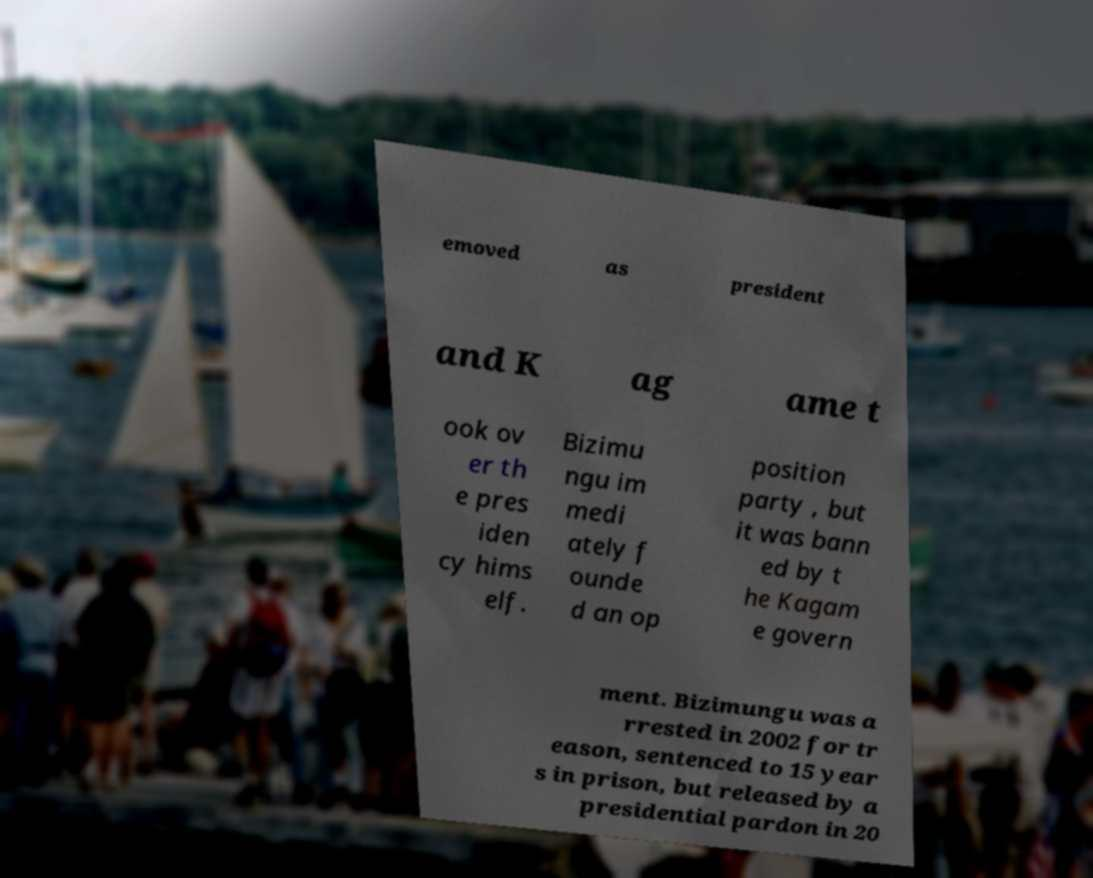Could you extract and type out the text from this image? emoved as president and K ag ame t ook ov er th e pres iden cy hims elf. Bizimu ngu im medi ately f ounde d an op position party , but it was bann ed by t he Kagam e govern ment. Bizimungu was a rrested in 2002 for tr eason, sentenced to 15 year s in prison, but released by a presidential pardon in 20 